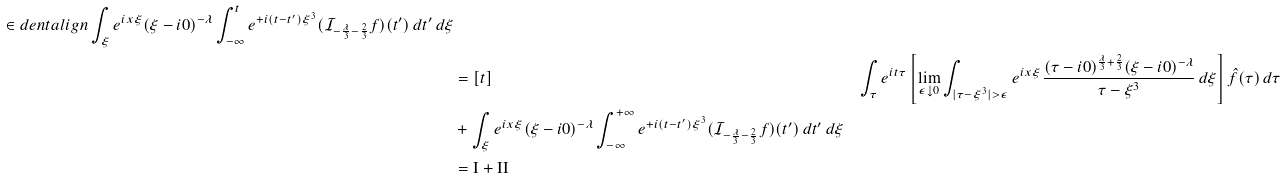Convert formula to latex. <formula><loc_0><loc_0><loc_500><loc_500>\in d e n t a l i g n \int _ { \xi } e ^ { i x \xi } ( \xi - i 0 ) ^ { - \lambda } \int _ { - \infty } ^ { t } e ^ { + i ( t - t ^ { \prime } ) \xi ^ { 3 } } ( \mathcal { I } _ { - \frac { \lambda } { 3 } - \frac { 2 } { 3 } } f ) ( t ^ { \prime } ) \, d t ^ { \prime } \, d \xi \\ & = [ t ] & \int _ { \tau } e ^ { i t \tau } \left [ \lim _ { \epsilon \downarrow 0 } \int _ { | \tau - \xi ^ { 3 } | > \epsilon } e ^ { i x \xi } \frac { ( \tau - i 0 ) ^ { \frac { \lambda } { 3 } + \frac { 2 } { 3 } } ( \xi - i 0 ) ^ { - \lambda } } { \tau - \xi ^ { 3 } } \, d \xi \right ] \hat { f } ( \tau ) \, d \tau \\ & + \int _ { \xi } e ^ { i x \xi } ( \xi - i 0 ) ^ { - \lambda } \int _ { - \infty } ^ { + \infty } e ^ { + i ( t - t ^ { \prime } ) \xi ^ { 3 } } ( \mathcal { I } _ { - \frac { \lambda } { 3 } - \frac { 2 } { 3 } } f ) ( t ^ { \prime } ) \, d t ^ { \prime } \, d \xi \\ & = \text {I} + \text {II}</formula> 